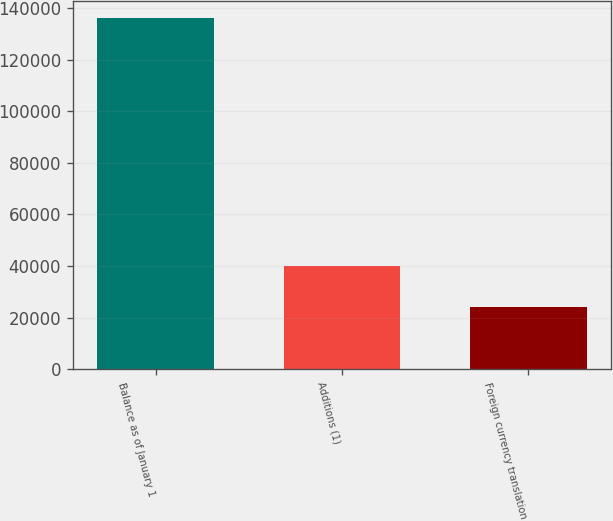Convert chart. <chart><loc_0><loc_0><loc_500><loc_500><bar_chart><fcel>Balance as of January 1<fcel>Additions (1)<fcel>Foreign currency translation<nl><fcel>136006<fcel>40124<fcel>24120<nl></chart> 